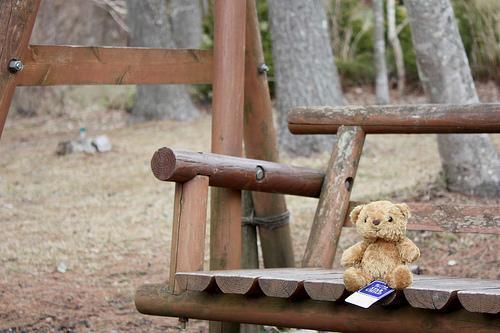How many bears are pictured?
Give a very brief answer. 1. 